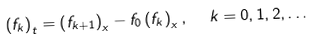<formula> <loc_0><loc_0><loc_500><loc_500>\left ( f _ { k } \right ) _ { t } = \left ( f _ { k + 1 } \right ) _ { x } - f _ { 0 } \left ( f _ { k } \right ) _ { x } , \text { \ } k = 0 , 1 , 2 , \dots</formula> 